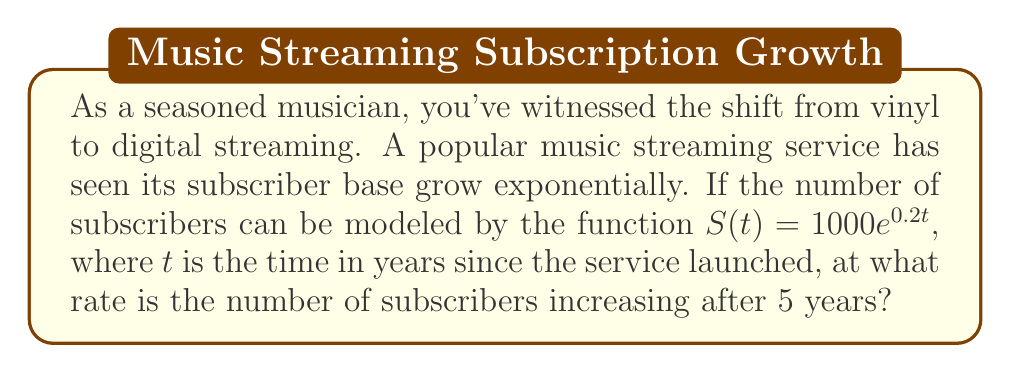Give your solution to this math problem. To find the rate of increase in subscribers after 5 years, we need to follow these steps:

1) The given function for the number of subscribers is:
   $S(t) = 1000e^{0.2t}$

2) To find the rate of change, we need to differentiate $S(t)$ with respect to $t$:
   $$\frac{dS}{dt} = 1000 \cdot 0.2e^{0.2t} = 200e^{0.2t}$$

3) This derivative represents the instantaneous rate of change in subscribers at any time $t$.

4) To find the rate after 5 years, we substitute $t=5$ into this derivative:
   $$\frac{dS}{dt}\bigg|_{t=5} = 200e^{0.2(5)} = 200e$$

5) Calculate the value:
   $200e \approx 543.8$

Therefore, after 5 years, the number of subscribers is increasing at a rate of approximately 543.8 subscribers per year.
Answer: 543.8 subscribers/year 